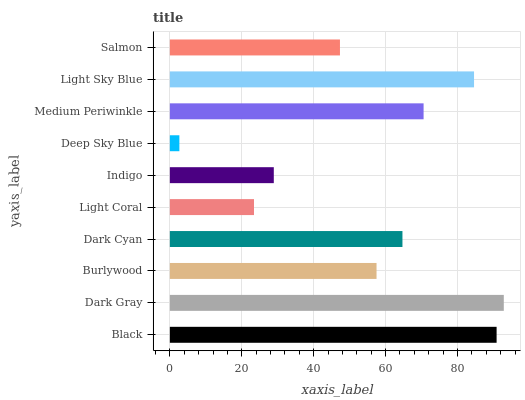Is Deep Sky Blue the minimum?
Answer yes or no. Yes. Is Dark Gray the maximum?
Answer yes or no. Yes. Is Burlywood the minimum?
Answer yes or no. No. Is Burlywood the maximum?
Answer yes or no. No. Is Dark Gray greater than Burlywood?
Answer yes or no. Yes. Is Burlywood less than Dark Gray?
Answer yes or no. Yes. Is Burlywood greater than Dark Gray?
Answer yes or no. No. Is Dark Gray less than Burlywood?
Answer yes or no. No. Is Dark Cyan the high median?
Answer yes or no. Yes. Is Burlywood the low median?
Answer yes or no. Yes. Is Burlywood the high median?
Answer yes or no. No. Is Salmon the low median?
Answer yes or no. No. 